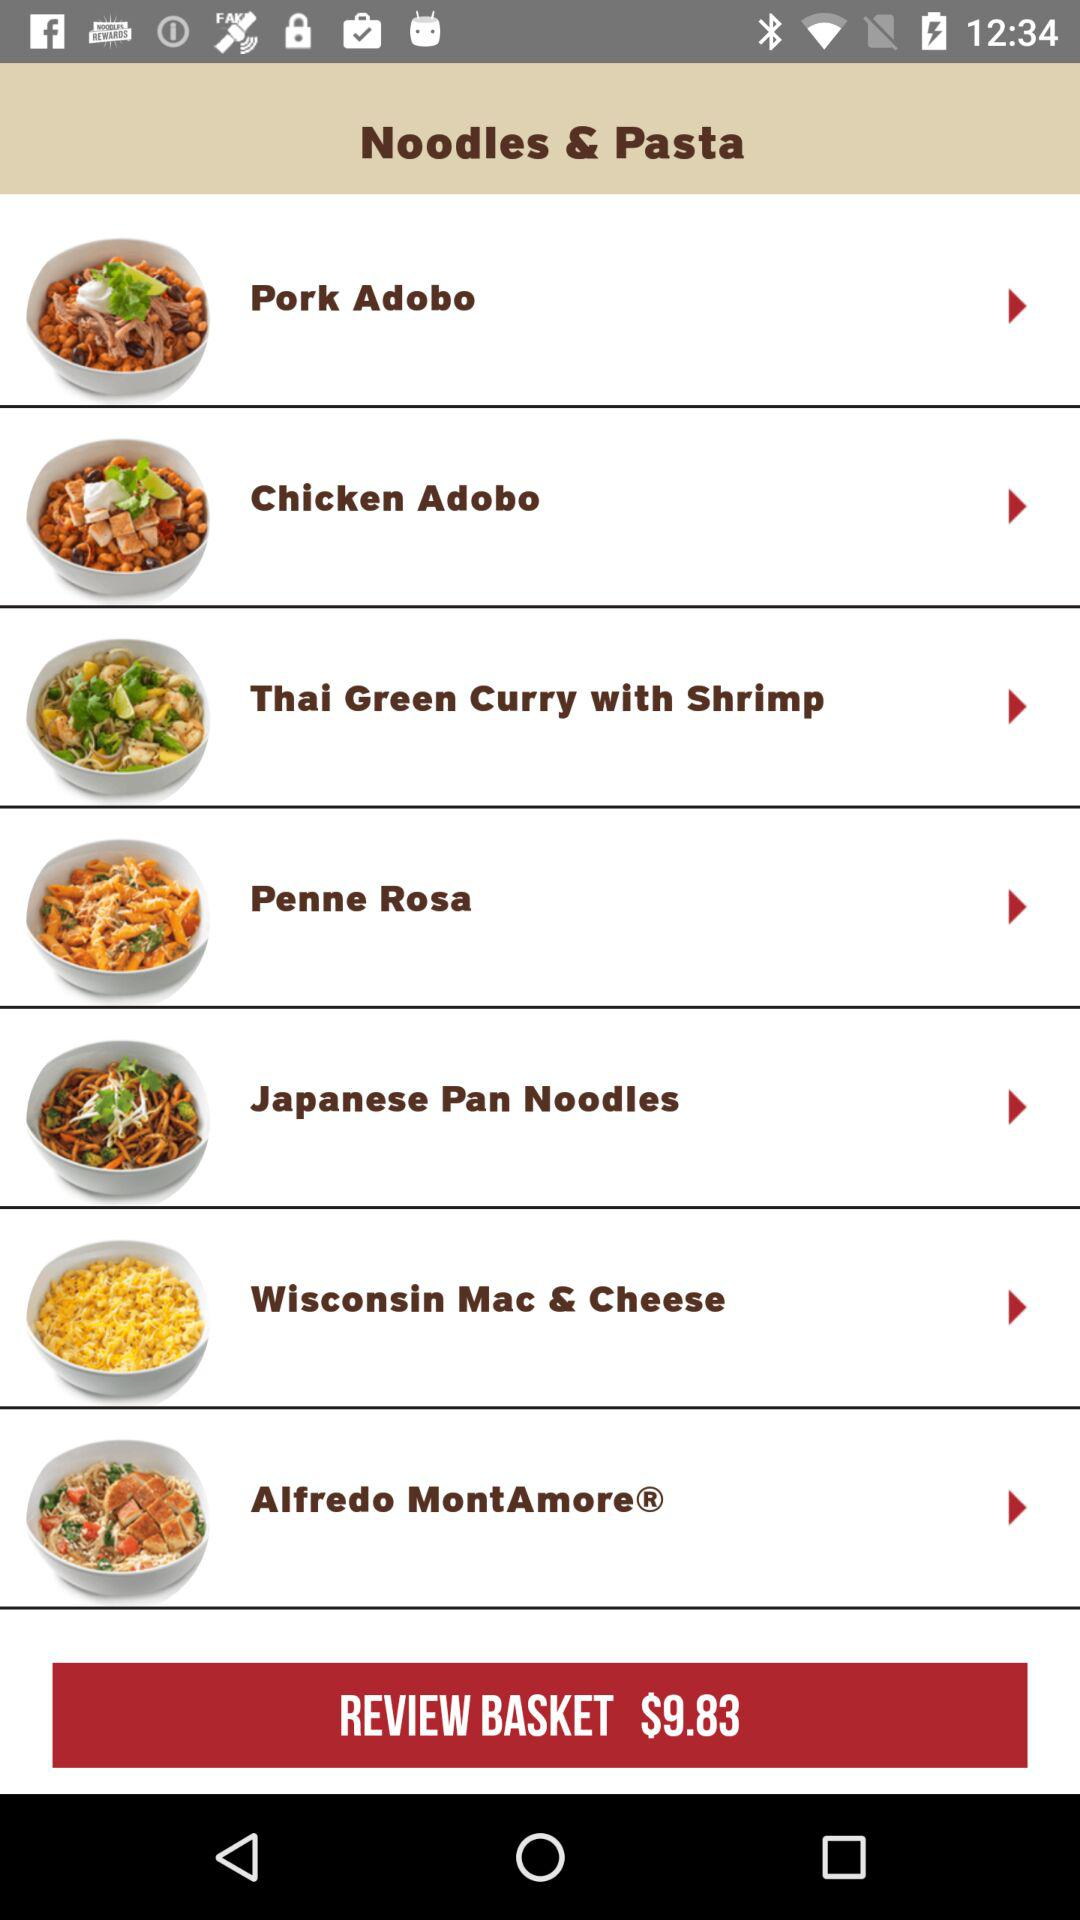How many noodles and pasta dishes are there?
Answer the question using a single word or phrase. 7 